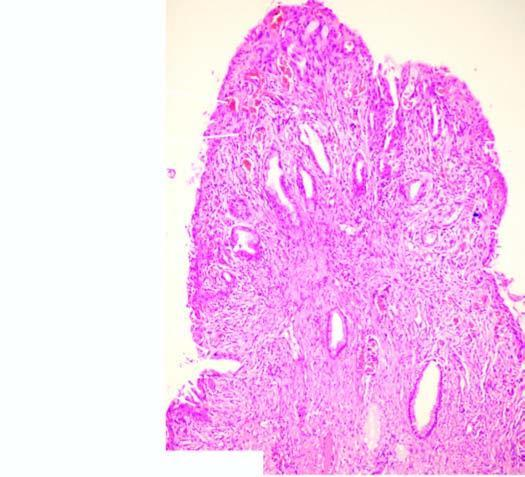what is composed of dense fibrous tissue which shows nonspecific inflammation?
Answer the question using a single word or phrase. Stromal core 